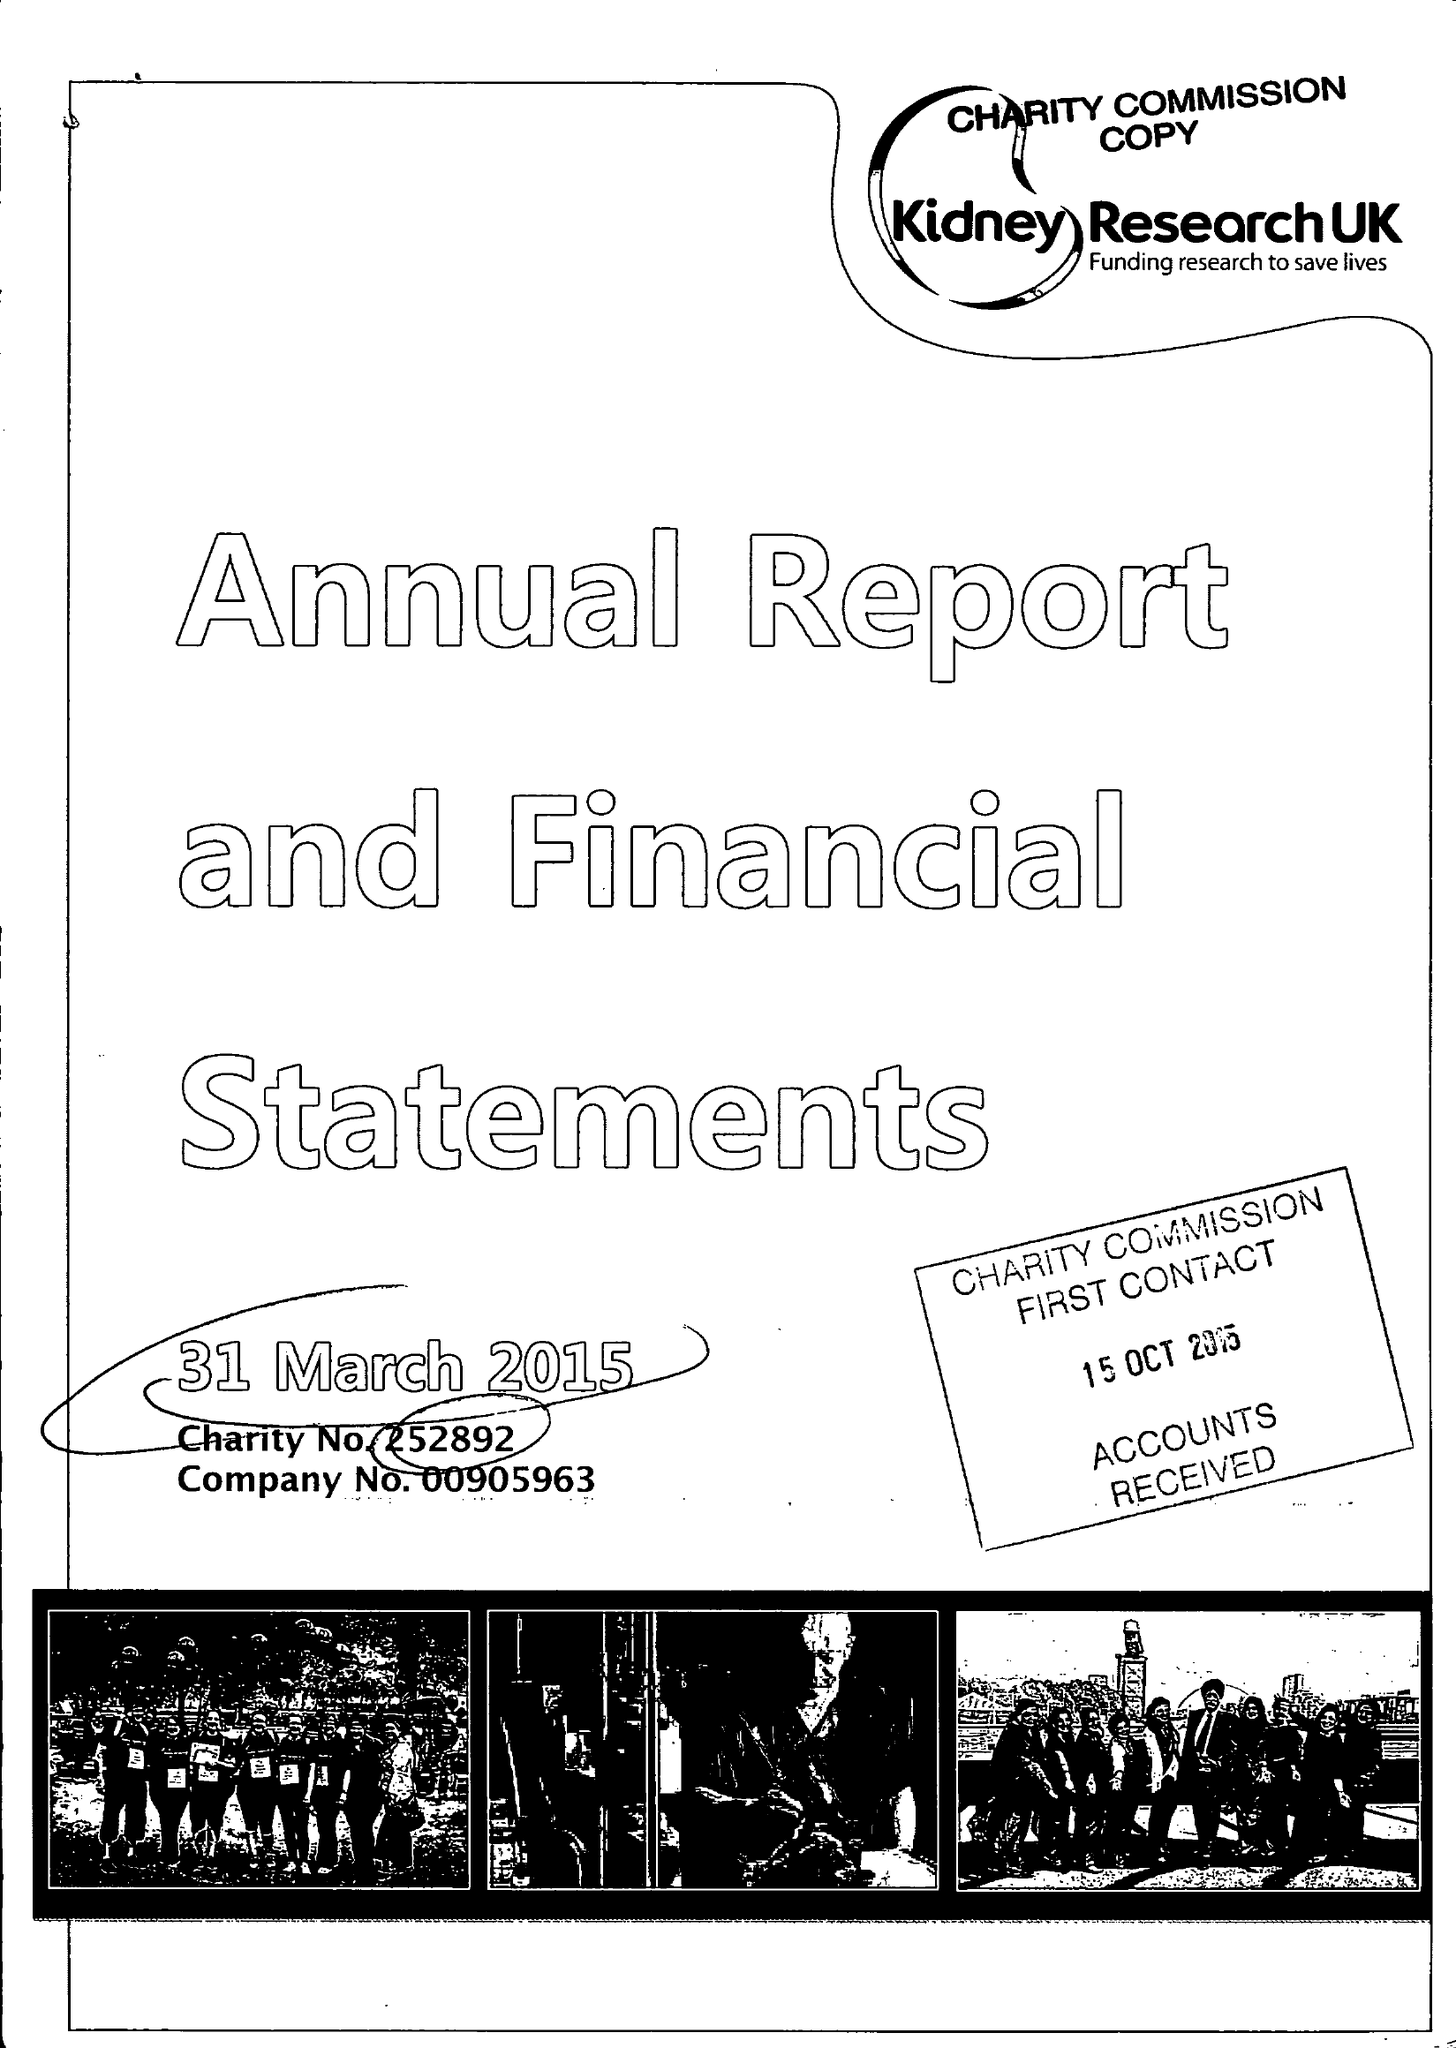What is the value for the charity_name?
Answer the question using a single word or phrase. Kidney Research Uk 